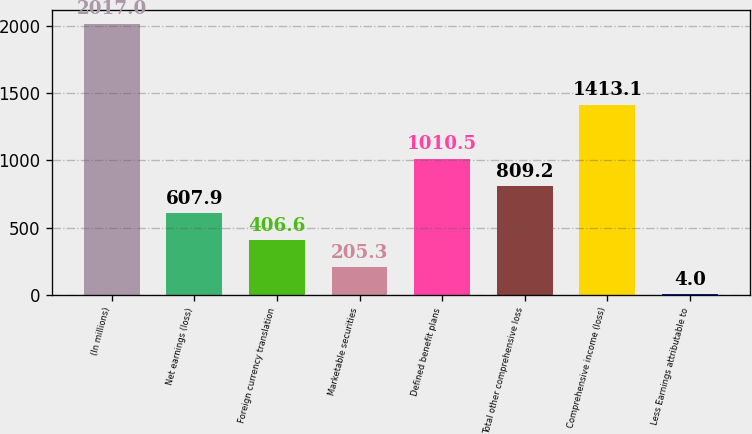<chart> <loc_0><loc_0><loc_500><loc_500><bar_chart><fcel>(In millions)<fcel>Net earnings (loss)<fcel>Foreign currency translation<fcel>Marketable securities<fcel>Defined benefit plans<fcel>Total other comprehensive loss<fcel>Comprehensive income (loss)<fcel>Less Earnings attributable to<nl><fcel>2017<fcel>607.9<fcel>406.6<fcel>205.3<fcel>1010.5<fcel>809.2<fcel>1413.1<fcel>4<nl></chart> 